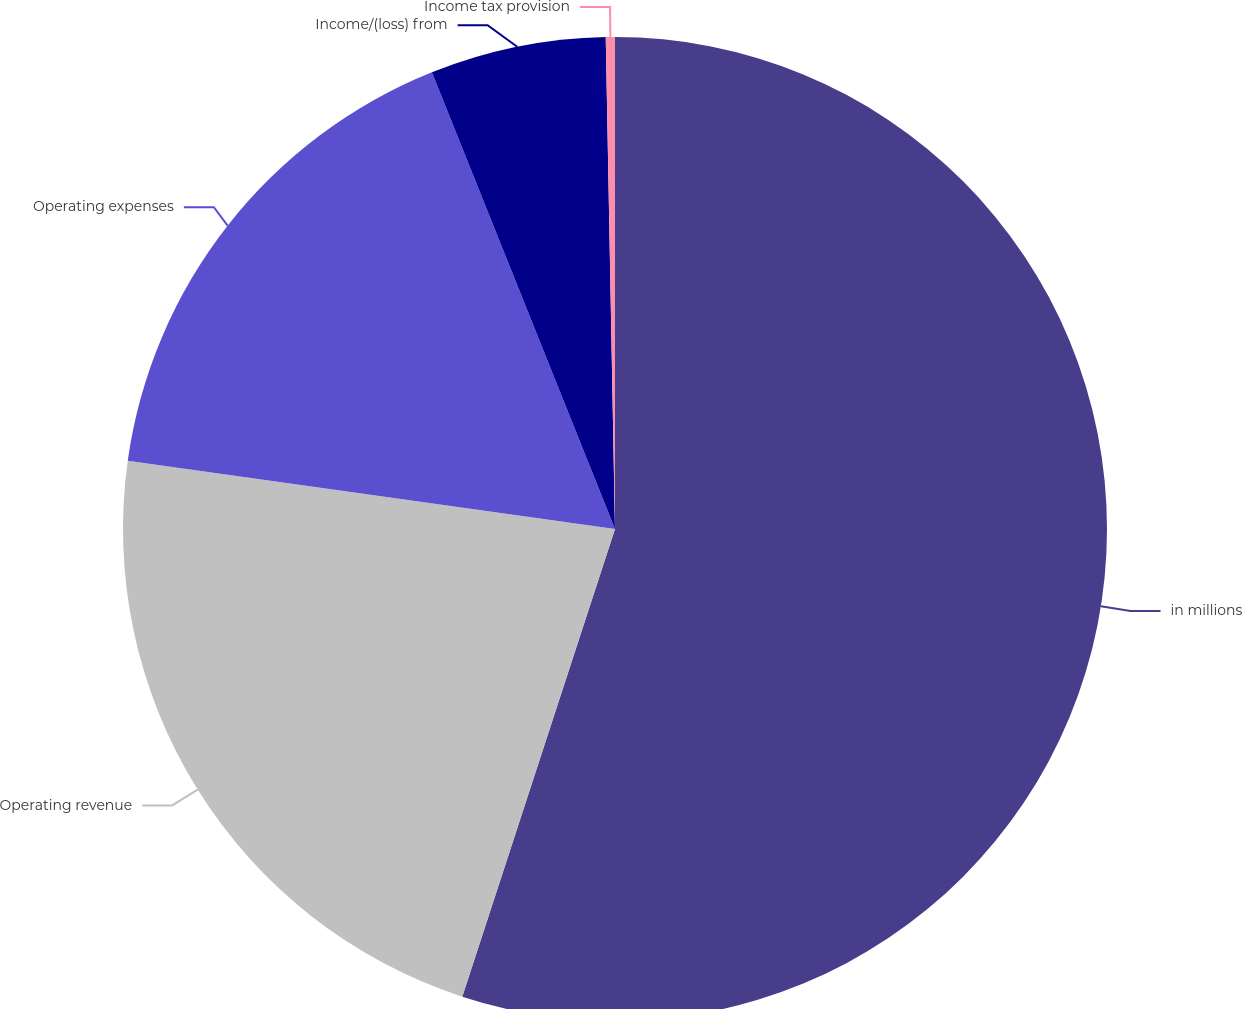<chart> <loc_0><loc_0><loc_500><loc_500><pie_chart><fcel>in millions<fcel>Operating revenue<fcel>Operating expenses<fcel>Income/(loss) from<fcel>Income tax provision<nl><fcel>55.03%<fcel>22.19%<fcel>16.72%<fcel>5.77%<fcel>0.3%<nl></chart> 